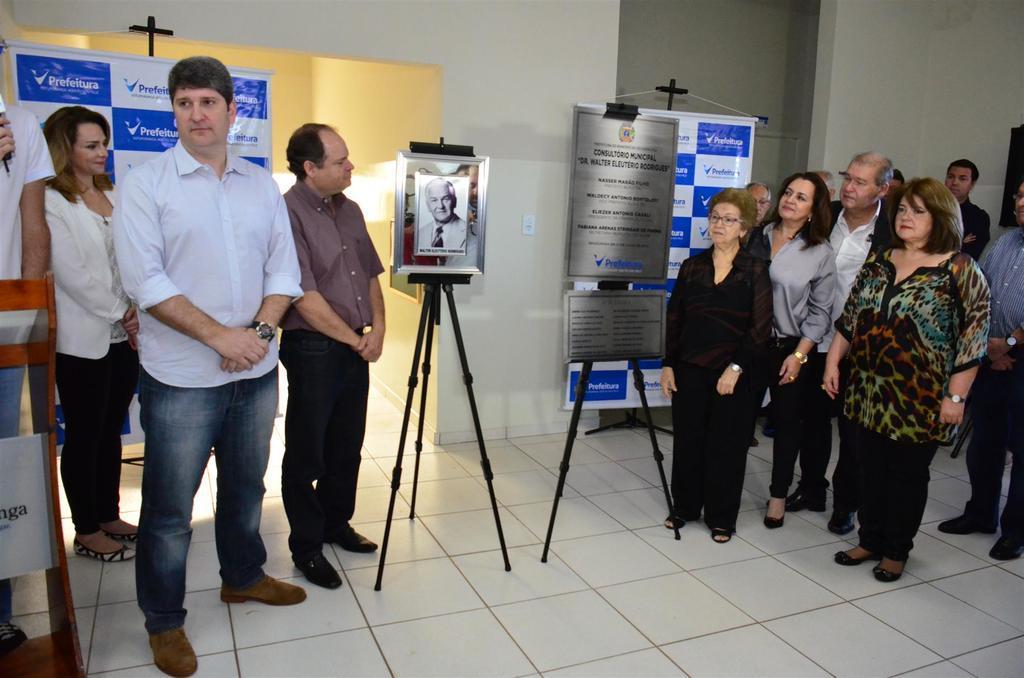Describe this image in one or two sentences. In this picture I can see number of people who are standing on the floor and in the center of this picture I can see the tripods, on which there is a photo frame and 2 boards on which there is something written. In the background I can see the wall and I see 2 banners on which there are words written. On the left side of this image I can see a stand on which there is a white color paper and I see alphabets on it. 